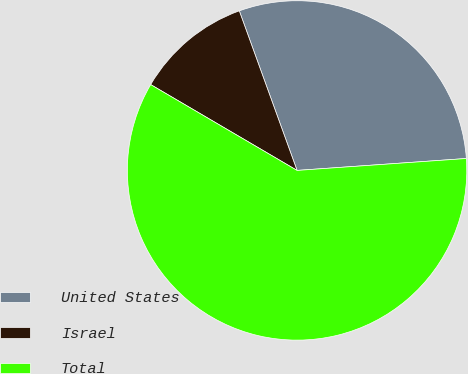Convert chart. <chart><loc_0><loc_0><loc_500><loc_500><pie_chart><fcel>United States<fcel>Israel<fcel>Total<nl><fcel>29.41%<fcel>11.03%<fcel>59.56%<nl></chart> 